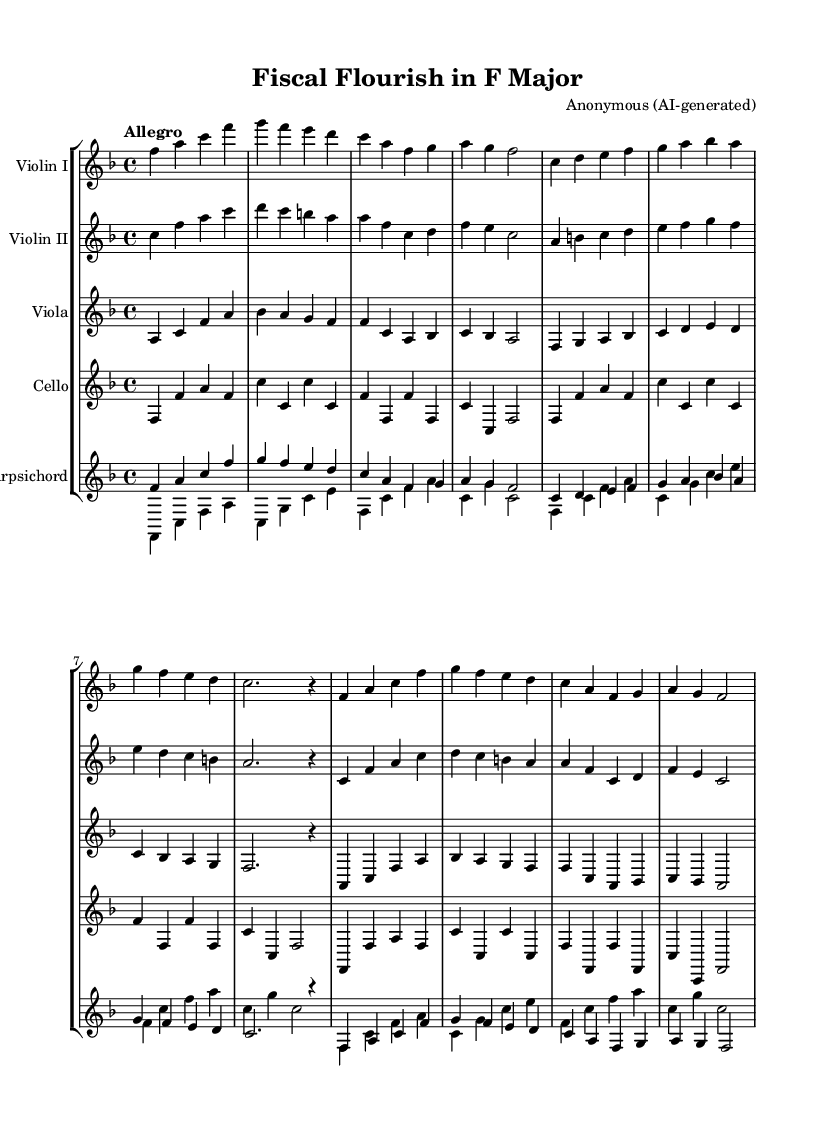What is the key signature of this music? The key signature is F major, which contains one flat (B flat). This can be identified by looking at the beginning of the staff where the flat is notated.
Answer: F major What is the time signature of this piece? The time signature indicated in the music is 4/4, which means there are four beats per measure and the quarter note gets one beat. This is evident from the notation placed after the clef at the beginning of the staff.
Answer: 4/4 What is the tempo marking of this composition? The tempo marking at the start specifies "Allegro," indicating a lively and fast pace. This is printed above the staff as an instruction for the performers to follow.
Answer: Allegro How many measures are in the piece? By counting the measures in the music, you can see there are 16 measures. Each measure is separated by vertical lines, making it easy to tally up the count.
Answer: 16 Which instruments are present in this orchestral piece? The instruments listed in the score include Violins I and II, Viola, Cello, and Harpsichord. Each instrument is named at the beginning of its respective staff, allowing performers to know who plays which part.
Answer: Violins, Viola, Cello, Harpsichord What thematic element of Baroque music can be identified in this piece? This orchestral piece includes a clear and energetic counterpoint common in Baroque music, where multiple melodies are interwoven, creating a rich texture. By analyzing the individual parts, you can observe this characteristic throughout the score.
Answer: Counterpoint 